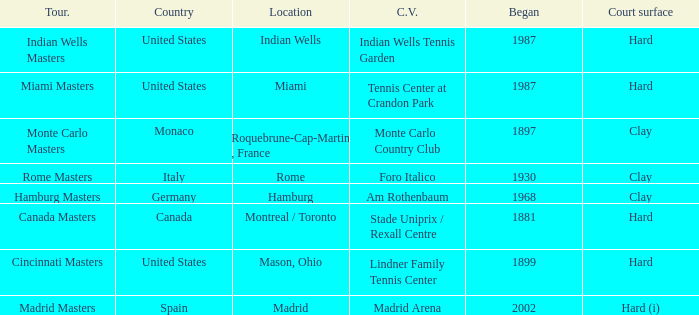How many tournaments have their current venue as the Lindner Family Tennis Center? 1.0. 